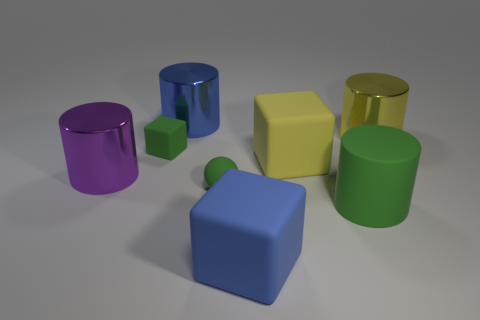Is the ball the same color as the tiny matte cube?
Give a very brief answer. Yes. The matte block that is the same color as the sphere is what size?
Provide a short and direct response. Small. Are there any large brown cylinders made of the same material as the blue block?
Offer a terse response. No. What shape is the big thing that is both behind the purple cylinder and in front of the big yellow metallic thing?
Offer a very short reply. Cube. What number of small objects are either blue metal objects or green metal spheres?
Offer a terse response. 0. What is the purple object made of?
Your response must be concise. Metal. What number of other things are there of the same shape as the big purple metallic thing?
Provide a succinct answer. 3. How big is the sphere?
Offer a terse response. Small. There is a cylinder that is behind the green matte block and to the left of the big yellow metal cylinder; how big is it?
Your answer should be compact. Large. What is the shape of the large metallic thing in front of the yellow shiny thing?
Make the answer very short. Cylinder. 